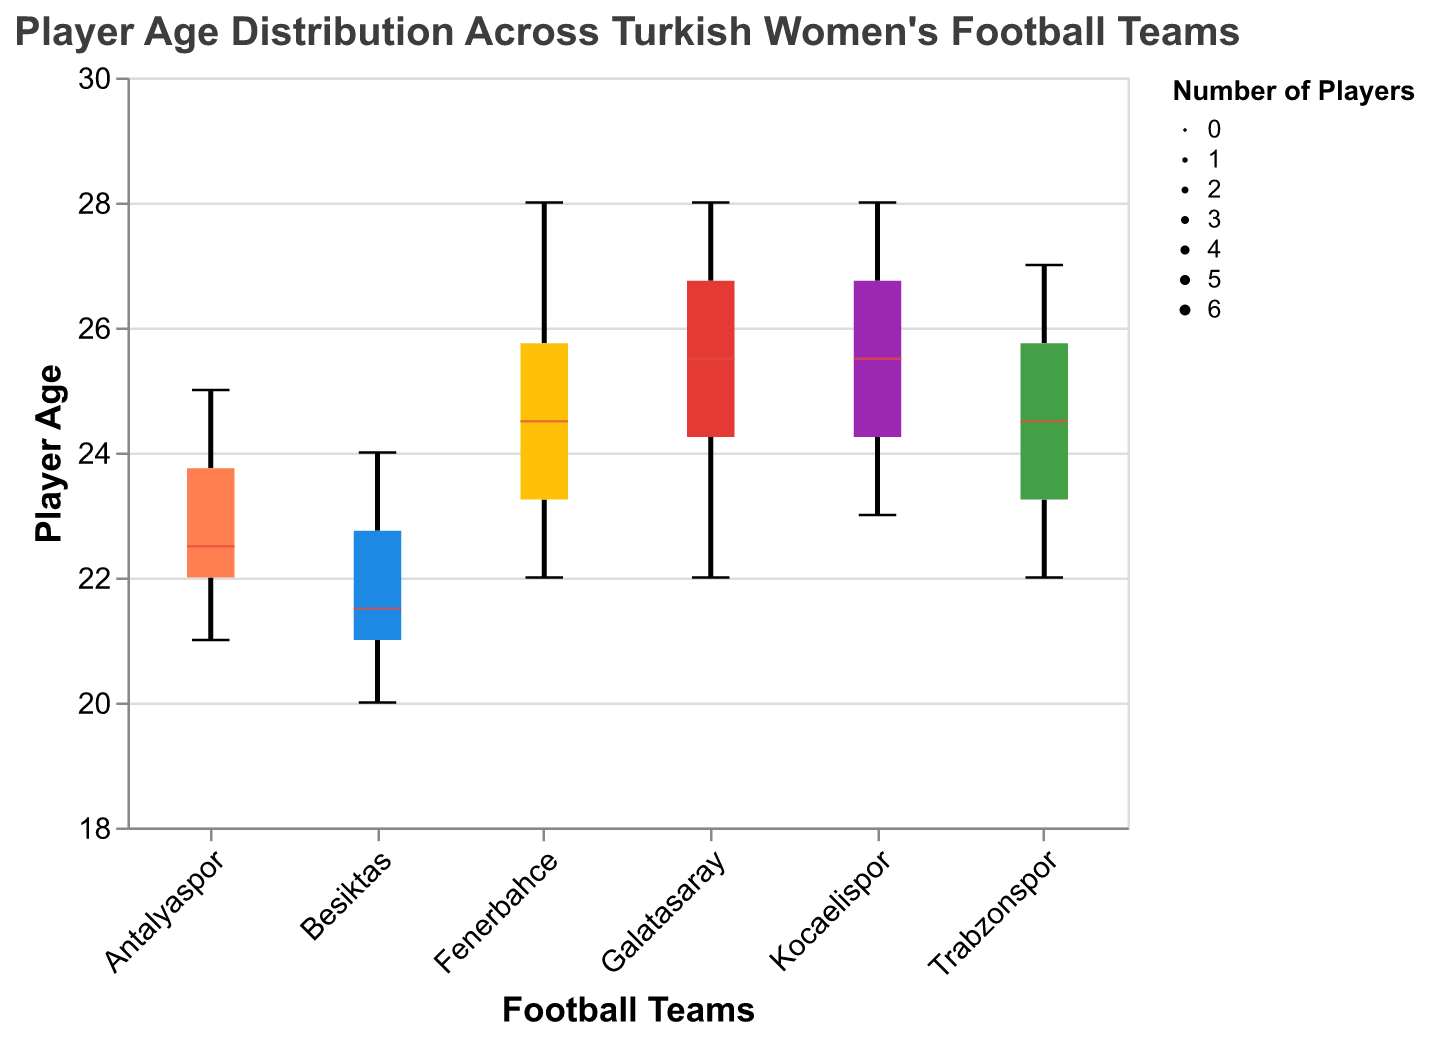What is the title of the figure? The title is directly displayed at the top of the figure in a larger font, indicating the primary subject of the plot.
Answer: Player Age Distribution Across Turkish Women's Football Teams Which team has the youngest player? By looking at the lower end of the box plots, the smallest age value represents the youngest player. For Besiktas, the minimum player age is 20.
Answer: Besiktas What is the age range for Fenerbahce? The range can be found by identifying the minimum and maximum values at the end of the whiskers for the Fenerbahce box plot, which range from 22 to 28.
Answer: 22 to 28 What is the median age of players for Galatasaray? The line inside the box plot for Galatasaray indicates the median age, which is colored differently in this plot using white. The line is at age 26.
Answer: 26 What is the interquartile range (IQR) for Kocaelispor? The IQR is the difference between the third quartile (Q3) and the first quartile (Q1) values of the Kocaelispor box plot. Q1 and Q3 are the edges of the box itself. For Kocaelispor, Q1 is 24 and Q3 is 27, so the IQR is 27 - 24.
Answer: 3 Which team has the highest median player age? By comparing the white median lines across all box plots, the team with the highest median line is seen in Fenerbahce, which is at 25.
Answer: Fenerbahce Which two teams have the most similar age distribution? To determine similarity in distributions, we look for box plots with similar median lines, ranges, and IQRs. Antalyaspor and Besiktas have very similar IQRs and ranges.
Answer: Antalyaspor and Besiktas Which team has the widest distribution of player ages? The widest distribution can be identified by finding the team box plot with the greatest distance between the minimum and maximum whiskers. Fenerbahce has the widest distribution from 22 to 28.
Answer: Fenerbahce Which team has the greatest number of players? In the variable width box plot, the width of the box suggests the count of players. The team with the widest box is Trabzonspor.
Answer: Trabzonspor 